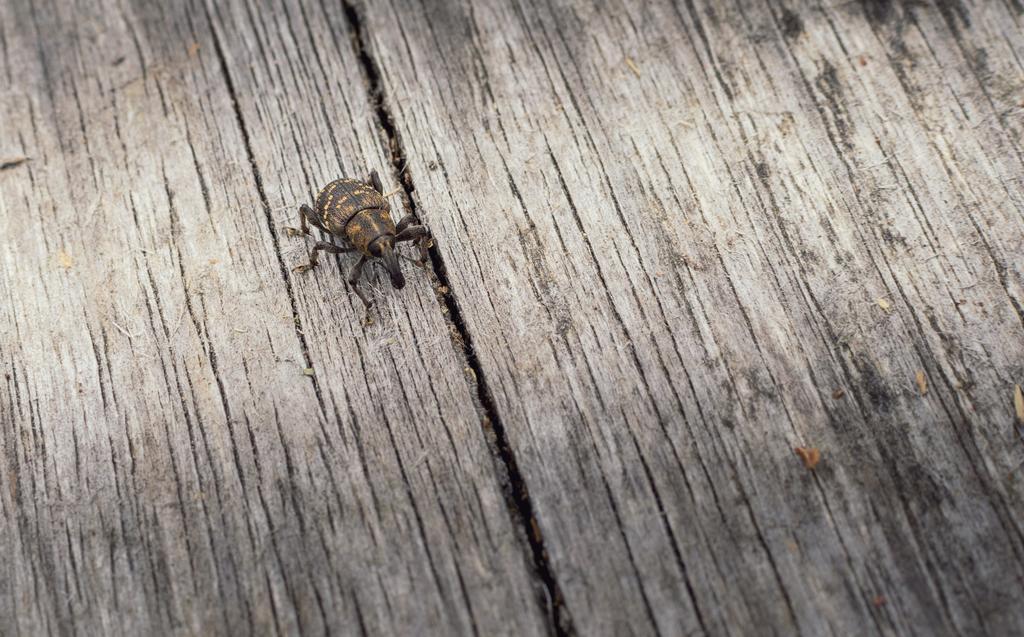In one or two sentences, can you explain what this image depicts? In this picture I can observe an insect on the wooden surface. This insect is in brown color. 